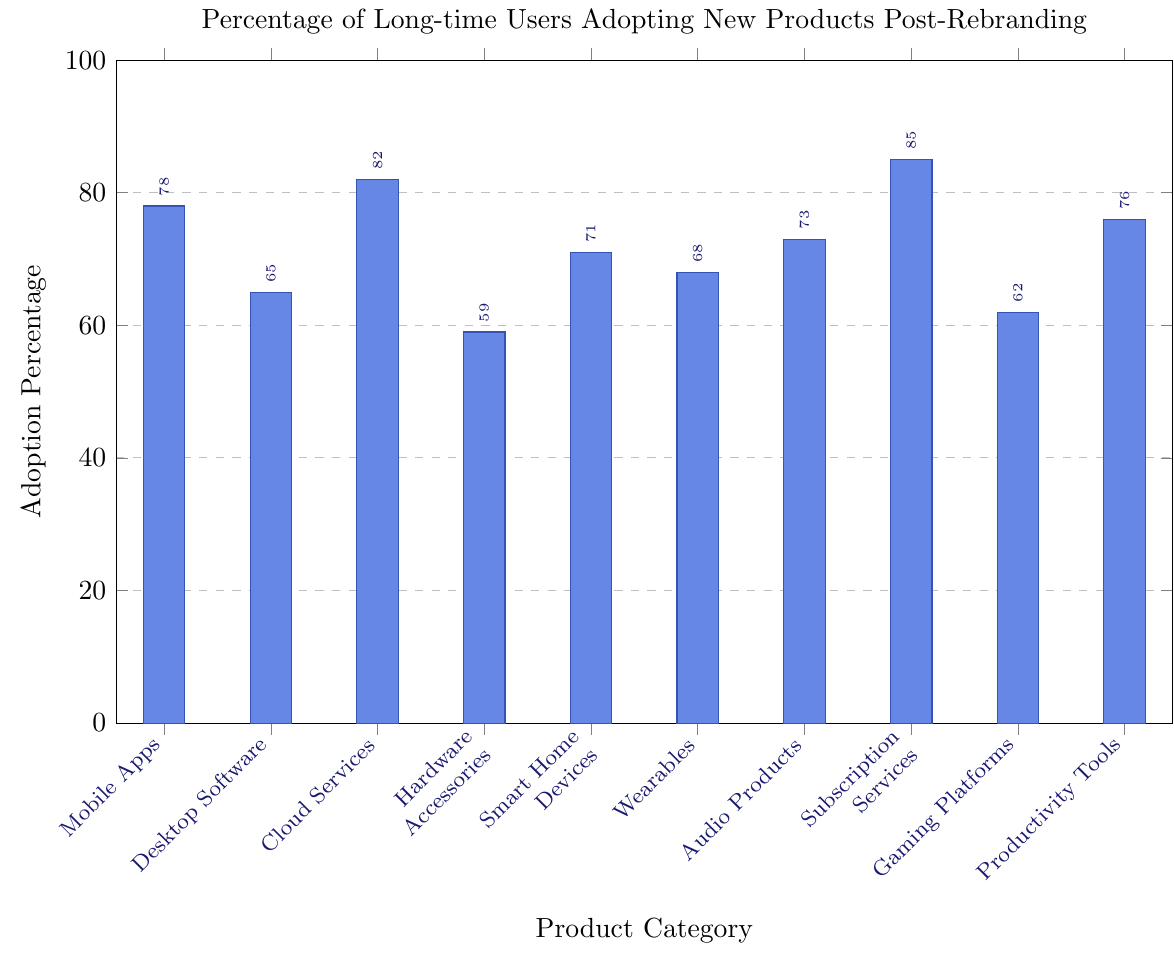what is the adoption percentage of Audio Products? The figure shows that the height of the bar for Audio Products corresponds to an adoption percentage of 73%
Answer: 73% What's the difference in adoption percentage between Cloud Services and Hardware Accessories? The adoption percentage for Cloud Services is 82%, and for Hardware Accessories, it is 59%. The difference is calculated as 82% - 59% = 23%
Answer: 23% Which product category has the highest adoption percentage? By comparing the heights of the bars, the Subscription Services bar is the tallest, indicating it has the highest adoption percentage at 85%
Answer: Subscription Services Are Wearables adopted more than Desktop Software? The adoption percentage for Wearables is 68%, and for Desktop Software, it is 65%. Since 68% > 65%, Wearables are adopted more
Answer: Yes What is the average adoption percentage across all product categories? The adoption percentages are: 78, 65, 82, 59, 71, 68, 73, 85, 62, 76. The sum of these percentages is 719, and there are 10 categories. So, the average is 719/10 = 71.9%
Answer: 71.9% What's the relative increase in adoption percentage from Hardware Accessories to Smart Home Devices? Adoption for Hardware Accessories is 59%, for Smart Home Devices is 71%. The relative increase is ((71-59)/59) * 100 = 20.34%
Answer: 20.34% Which product category has the lowest adoption percentage? By comparing the heights of the bars, the Hardware Accessories bar is the shortest, indicating the lowest adoption percentage at 59%
Answer: Hardware Accessories Is the adoption percentage of Mobile Apps greater than that of Productivity Tools? The adoption percentage for Mobile Apps is 78%, and for Productivity Tools, it is 76%. Since 78% > 76%, Mobile Apps have a higher adoption percentage
Answer: Yes What is the median adoption percentage among the product categories? First, list the adoption percentages in ascending order: 59, 62, 65, 68, 71, 73, 76, 78, 82, 85. The median is the average of the 5th and 6th values: (71 + 73)/2 = 72%
Answer: 72% Which product categories have adoption percentages that are greater than the average adoption percentage? The average adoption percentage is 71.9%. Categories with greater percentages are: Mobile Apps (78), Cloud Services (82), Smart Home Devices (71), Audio Products (73), Subscription Services (85), and Productivity Tools (76)
Answer: Mobile Apps, Cloud Services, Audio Products, Subscription Services, Productivity Tools 